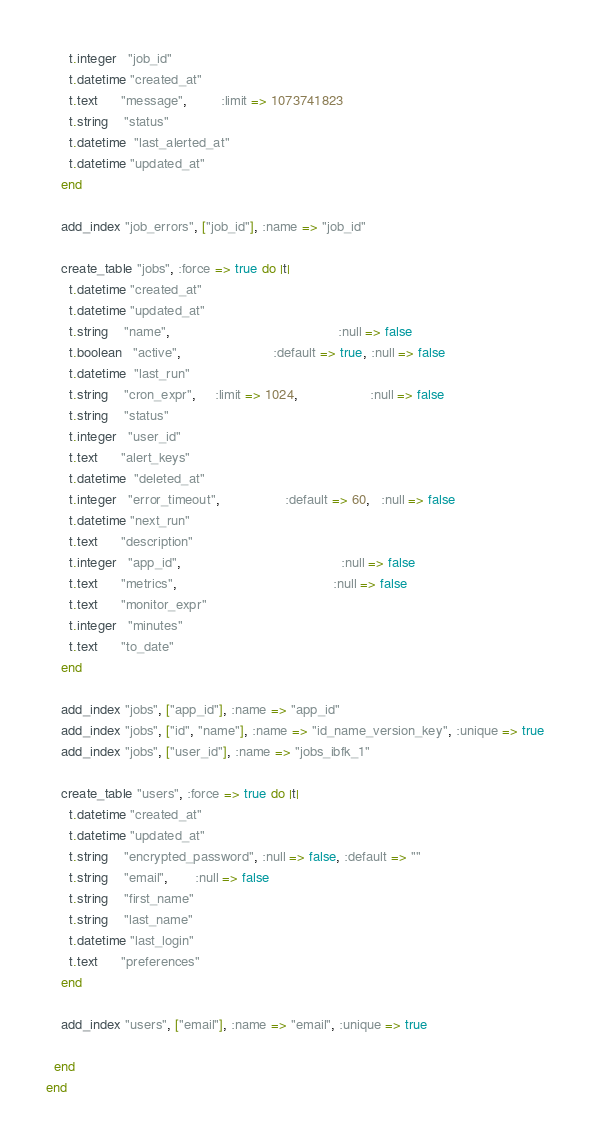Convert code to text. <code><loc_0><loc_0><loc_500><loc_500><_Ruby_>      t.integer   "job_id"
      t.datetime "created_at"
      t.text      "message",         :limit => 1073741823
      t.string    "status"
      t.datetime  "last_alerted_at"
      t.datetime "updated_at"
    end

    add_index "job_errors", ["job_id"], :name => "job_id"

    create_table "jobs", :force => true do |t|
      t.datetime "created_at"
      t.datetime "updated_at"
      t.string    "name",                                            :null => false
      t.boolean   "active",                        :default => true, :null => false
      t.datetime  "last_run"
      t.string    "cron_expr",     :limit => 1024,                   :null => false
      t.string    "status"
      t.integer   "user_id"
      t.text      "alert_keys"
      t.datetime  "deleted_at"
      t.integer   "error_timeout",                 :default => 60,   :null => false
      t.datetime "next_run"
      t.text      "description"
      t.integer   "app_id",                                          :null => false
      t.text      "metrics",                                         :null => false
      t.text      "monitor_expr"
      t.integer   "minutes"
      t.text      "to_date"
    end

    add_index "jobs", ["app_id"], :name => "app_id"
    add_index "jobs", ["id", "name"], :name => "id_name_version_key", :unique => true
    add_index "jobs", ["user_id"], :name => "jobs_ibfk_1"

    create_table "users", :force => true do |t|
      t.datetime "created_at"
      t.datetime "updated_at"
      t.string    "encrypted_password", :null => false, :default => ""
      t.string    "email",       :null => false
      t.string    "first_name"
      t.string    "last_name"
      t.datetime "last_login"
      t.text      "preferences"
    end

    add_index "users", ["email"], :name => "email", :unique => true

  end
end
</code> 